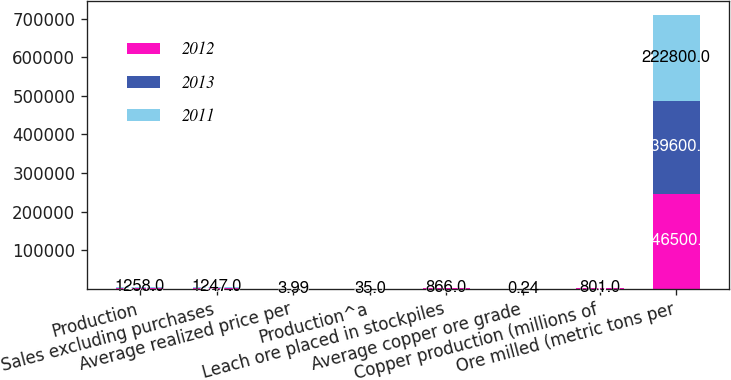<chart> <loc_0><loc_0><loc_500><loc_500><stacked_bar_chart><ecel><fcel>Production<fcel>Sales excluding purchases<fcel>Average realized price per<fcel>Production^a<fcel>Leach ore placed in stockpiles<fcel>Average copper ore grade<fcel>Copper production (millions of<fcel>Ore milled (metric tons per<nl><fcel>2012<fcel>1431<fcel>1422<fcel>3.36<fcel>32<fcel>866<fcel>0.22<fcel>889<fcel>246500<nl><fcel>2013<fcel>1363<fcel>1351<fcel>3.64<fcel>36<fcel>866<fcel>0.22<fcel>866<fcel>239600<nl><fcel>2011<fcel>1258<fcel>1247<fcel>3.99<fcel>35<fcel>866<fcel>0.24<fcel>801<fcel>222800<nl></chart> 